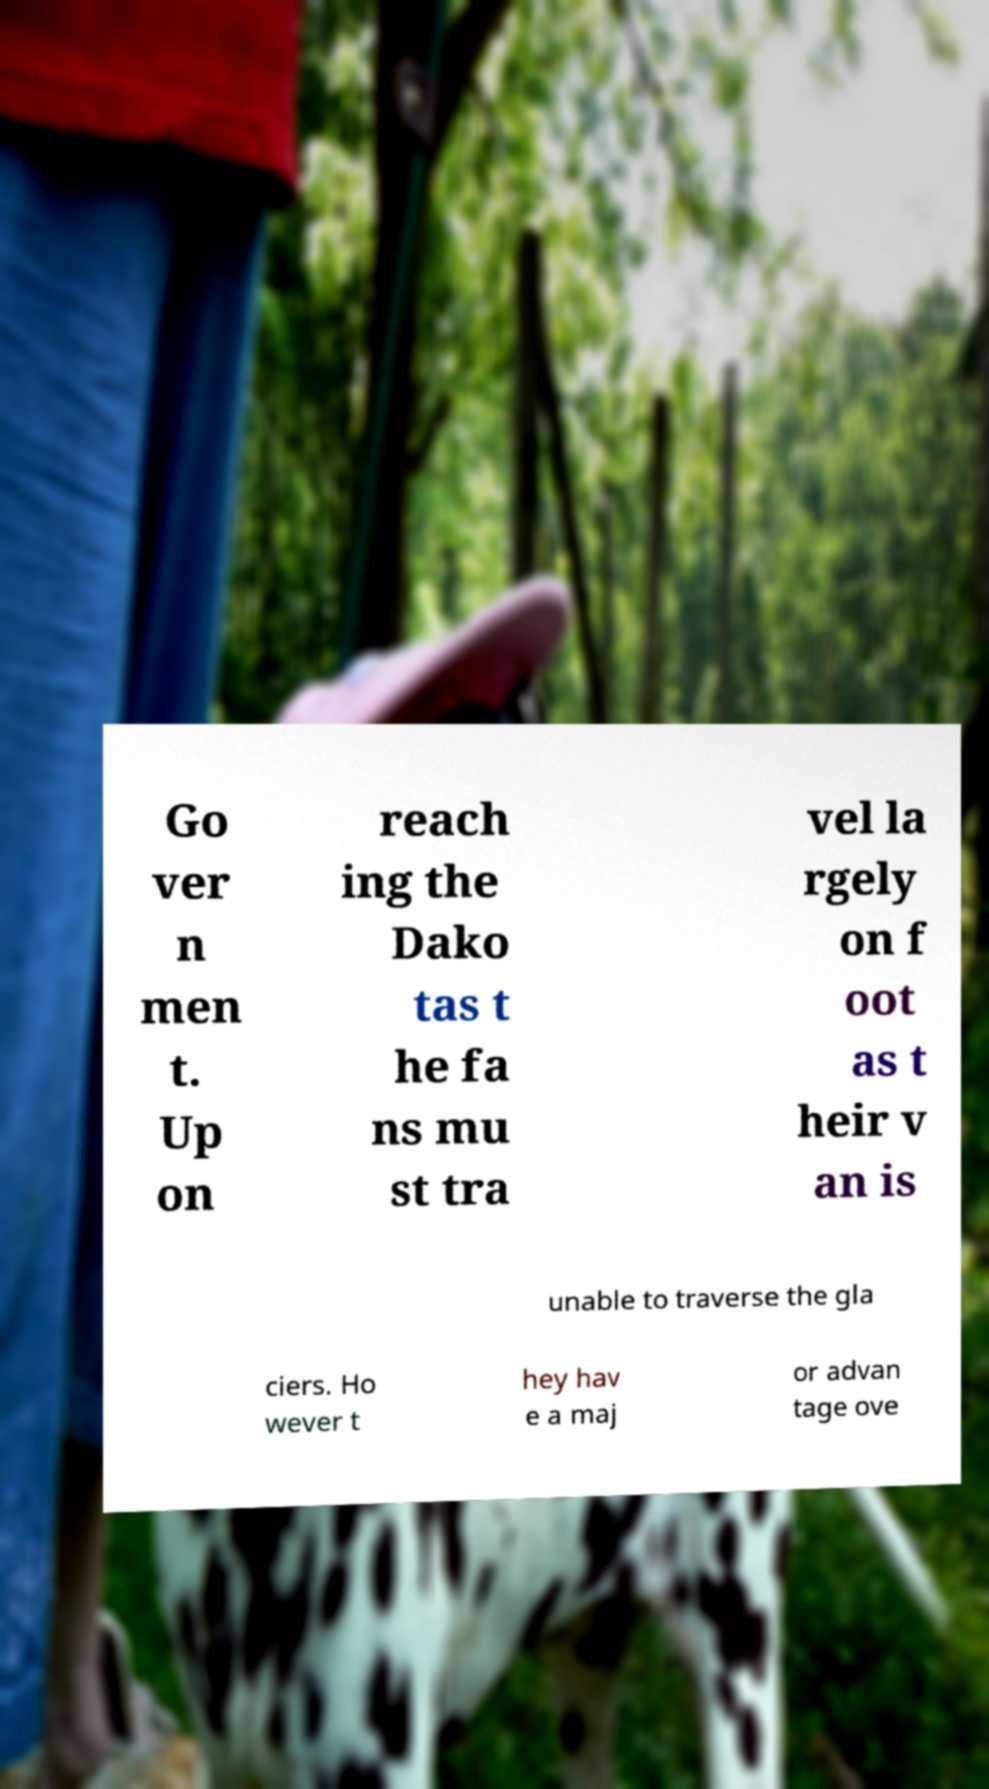What messages or text are displayed in this image? I need them in a readable, typed format. Go ver n men t. Up on reach ing the Dako tas t he fa ns mu st tra vel la rgely on f oot as t heir v an is unable to traverse the gla ciers. Ho wever t hey hav e a maj or advan tage ove 